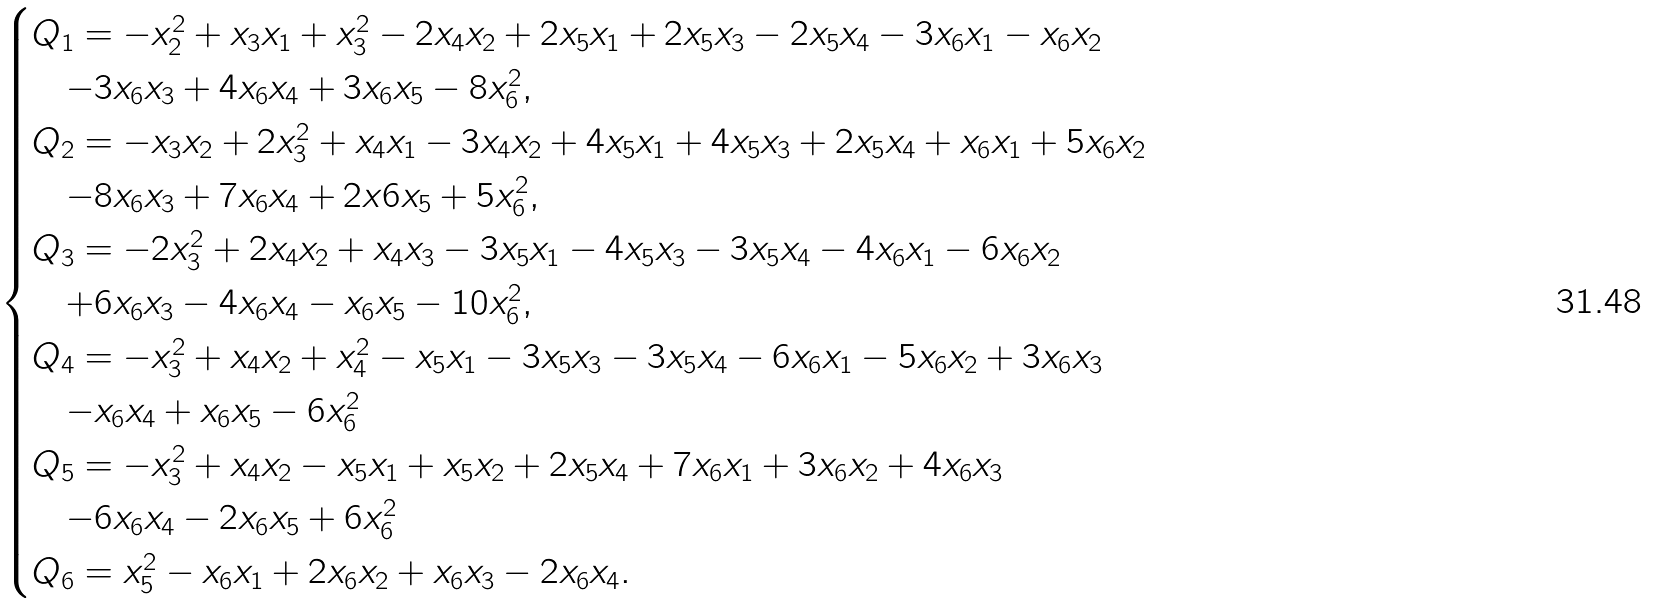Convert formula to latex. <formula><loc_0><loc_0><loc_500><loc_500>\begin{cases} Q _ { 1 } = - x _ { 2 } ^ { 2 } + x _ { 3 } x _ { 1 } + x _ { 3 } ^ { 2 } - 2 x _ { 4 } x _ { 2 } + 2 x _ { 5 } x _ { 1 } + 2 x _ { 5 } x _ { 3 } - 2 x _ { 5 } x _ { 4 } - 3 x _ { 6 } x _ { 1 } - x _ { 6 } x _ { 2 } \\ \quad - 3 x _ { 6 } x _ { 3 } + 4 x _ { 6 } x _ { 4 } + 3 x _ { 6 } x _ { 5 } - 8 x _ { 6 } ^ { 2 } , \\ Q _ { 2 } = - x _ { 3 } x _ { 2 } + 2 x _ { 3 } ^ { 2 } + x _ { 4 } x _ { 1 } - 3 x _ { 4 } x _ { 2 } + 4 x _ { 5 } x _ { 1 } + 4 x _ { 5 } x _ { 3 } + 2 x _ { 5 } x _ { 4 } + x _ { 6 } x _ { 1 } + 5 x _ { 6 } x _ { 2 } \\ \quad - 8 x _ { 6 } x _ { 3 } + 7 x _ { 6 } x _ { 4 } + 2 x 6 x _ { 5 } + 5 x _ { 6 } ^ { 2 } , \\ Q _ { 3 } = - 2 x _ { 3 } ^ { 2 } + 2 x _ { 4 } x _ { 2 } + x _ { 4 } x _ { 3 } - 3 x _ { 5 } x _ { 1 } - 4 x _ { 5 } x _ { 3 } - 3 x _ { 5 } x _ { 4 } - 4 x _ { 6 } x _ { 1 } - 6 x _ { 6 } x _ { 2 } \\ \quad + 6 x _ { 6 } x _ { 3 } - 4 x _ { 6 } x _ { 4 } - x _ { 6 } x _ { 5 } - 1 0 x _ { 6 } ^ { 2 } , \\ Q _ { 4 } = - x _ { 3 } ^ { 2 } + x _ { 4 } x _ { 2 } + x _ { 4 } ^ { 2 } - x _ { 5 } x _ { 1 } - 3 x _ { 5 } x _ { 3 } - 3 x _ { 5 } x _ { 4 } - 6 x _ { 6 } x _ { 1 } - 5 x _ { 6 } x _ { 2 } + 3 x _ { 6 } x _ { 3 } \\ \quad - x _ { 6 } x _ { 4 } + x _ { 6 } x _ { 5 } - 6 x _ { 6 } ^ { 2 } \\ Q _ { 5 } = - x _ { 3 } ^ { 2 } + x _ { 4 } x _ { 2 } - x _ { 5 } x _ { 1 } + x _ { 5 } x _ { 2 } + 2 x _ { 5 } x _ { 4 } + 7 x _ { 6 } x _ { 1 } + 3 x _ { 6 } x _ { 2 } + 4 x _ { 6 } x _ { 3 } \\ \quad - 6 x _ { 6 } x _ { 4 } - 2 x _ { 6 } x _ { 5 } + 6 x _ { 6 } ^ { 2 } \\ Q _ { 6 } = x _ { 5 } ^ { 2 } - x _ { 6 } x _ { 1 } + 2 x _ { 6 } x _ { 2 } + x _ { 6 } x _ { 3 } - 2 x _ { 6 } x _ { 4 } . \end{cases}</formula> 